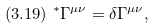Convert formula to latex. <formula><loc_0><loc_0><loc_500><loc_500>( 3 . 1 9 ) \ ^ { * } \Gamma ^ { \mu \nu } = \delta \Gamma ^ { \mu \nu } ,</formula> 